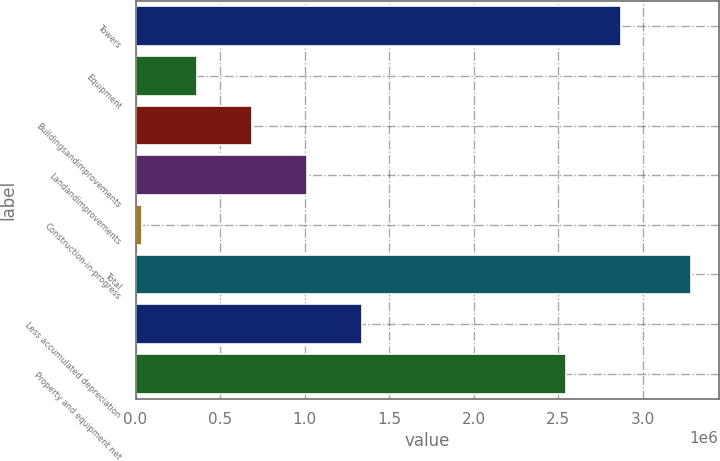Convert chart to OTSL. <chart><loc_0><loc_0><loc_500><loc_500><bar_chart><fcel>Towers<fcel>Equipment<fcel>Buildingsandimprovements<fcel>Landandimprovements<fcel>Construction-in-progress<fcel>Total<fcel>Less accumulated depreciation<fcel>Property and equipment net<nl><fcel>2.87113e+06<fcel>363286<fcel>687889<fcel>1.01249e+06<fcel>38683<fcel>3.28471e+06<fcel>1.3371e+06<fcel>2.54652e+06<nl></chart> 